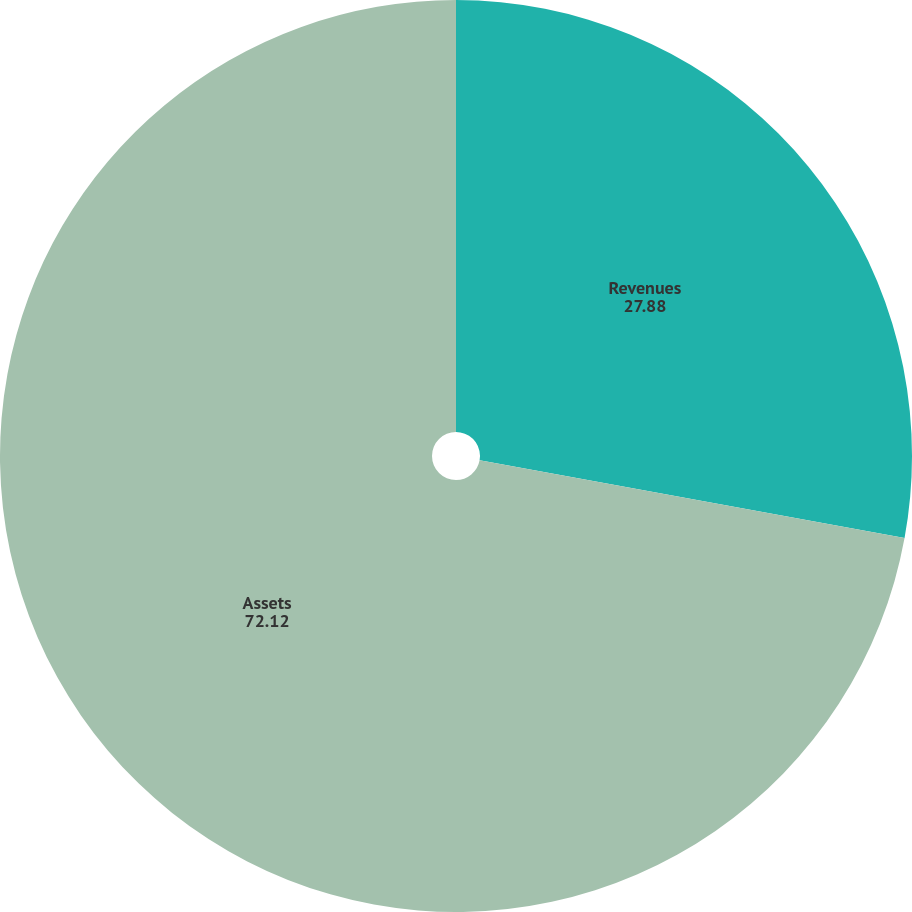Convert chart. <chart><loc_0><loc_0><loc_500><loc_500><pie_chart><fcel>Revenues<fcel>Assets<nl><fcel>27.88%<fcel>72.12%<nl></chart> 